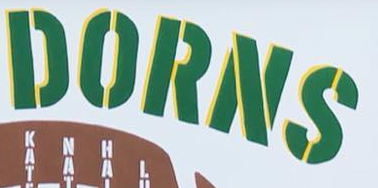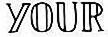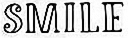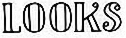Identify the words shown in these images in order, separated by a semicolon. DORNS; YOUR; SMILE; LOOKS 